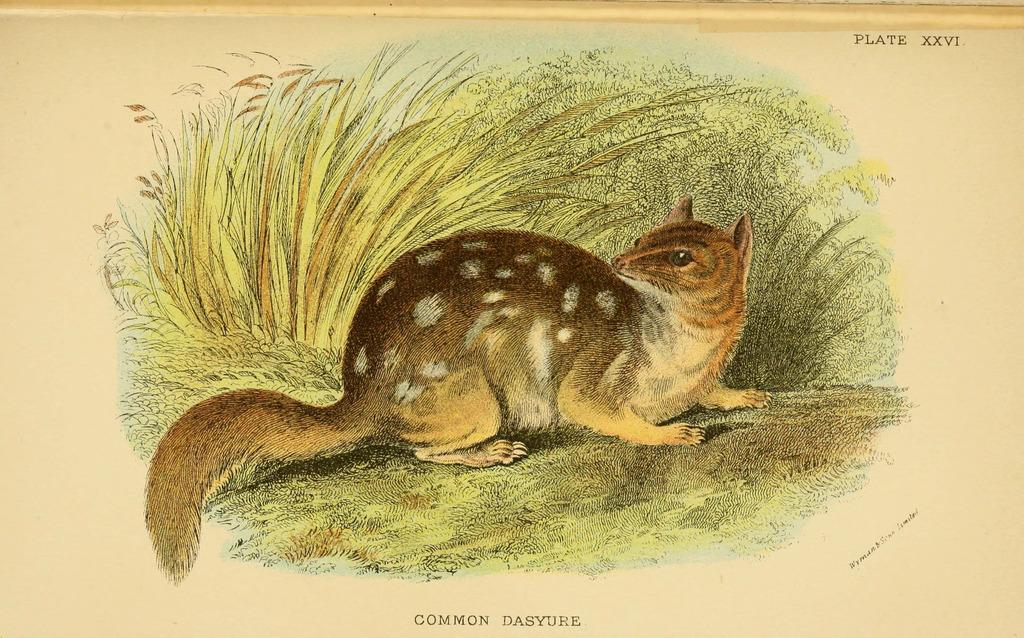What is the main subject of the picture in the image? There is a picture of a squirrel in the image. Where is the squirrel located in the picture? The squirrel is sitting on the grass in the picture. What is the picture printed on? The picture is on a piece of paper. What else can be seen on the paper besides the picture? There are texts written on the paper. What type of education does the squirrel have in the image? There is no indication of the squirrel's education in the image, as it is a picture of a squirrel sitting on the grass. How does the squirrel show respect to its partner in the image? There is no partner or indication of respect in the image, as it is a picture of a squirrel sitting on the grass. 